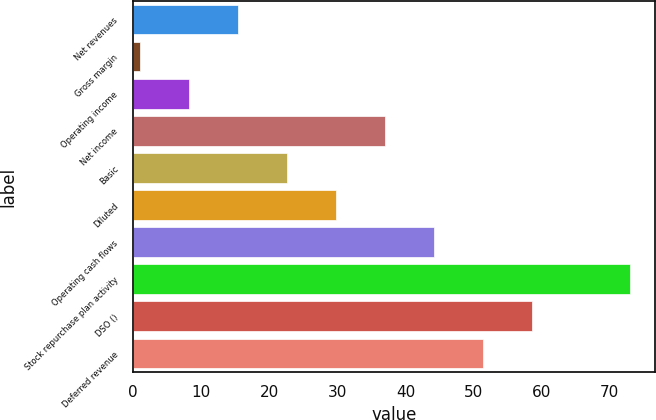Convert chart to OTSL. <chart><loc_0><loc_0><loc_500><loc_500><bar_chart><fcel>Net revenues<fcel>Gross margin<fcel>Operating income<fcel>Net income<fcel>Basic<fcel>Diluted<fcel>Operating cash flows<fcel>Stock repurchase plan activity<fcel>DSO ()<fcel>Deferred revenue<nl><fcel>15.4<fcel>1<fcel>8.2<fcel>37<fcel>22.6<fcel>29.8<fcel>44.2<fcel>73<fcel>58.6<fcel>51.4<nl></chart> 